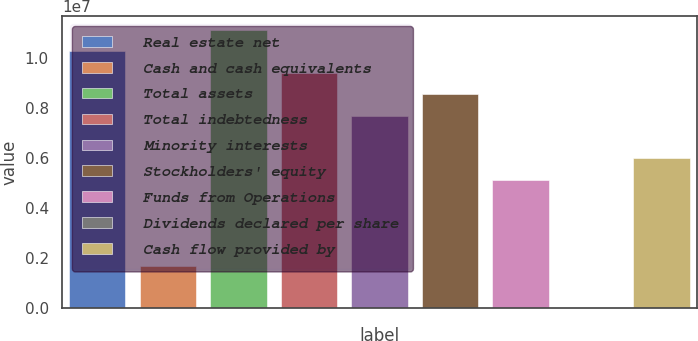Convert chart to OTSL. <chart><loc_0><loc_0><loc_500><loc_500><bar_chart><fcel>Real estate net<fcel>Cash and cash equivalents<fcel>Total assets<fcel>Total indebtedness<fcel>Minority interests<fcel>Stockholders' equity<fcel>Funds from Operations<fcel>Dividends declared per share<fcel>Cash flow provided by<nl><fcel>1.02613e+07<fcel>1.71022e+06<fcel>1.11164e+07<fcel>9.40621e+06<fcel>7.69599e+06<fcel>8.5511e+06<fcel>5.13066e+06<fcel>2.5<fcel>5.98577e+06<nl></chart> 